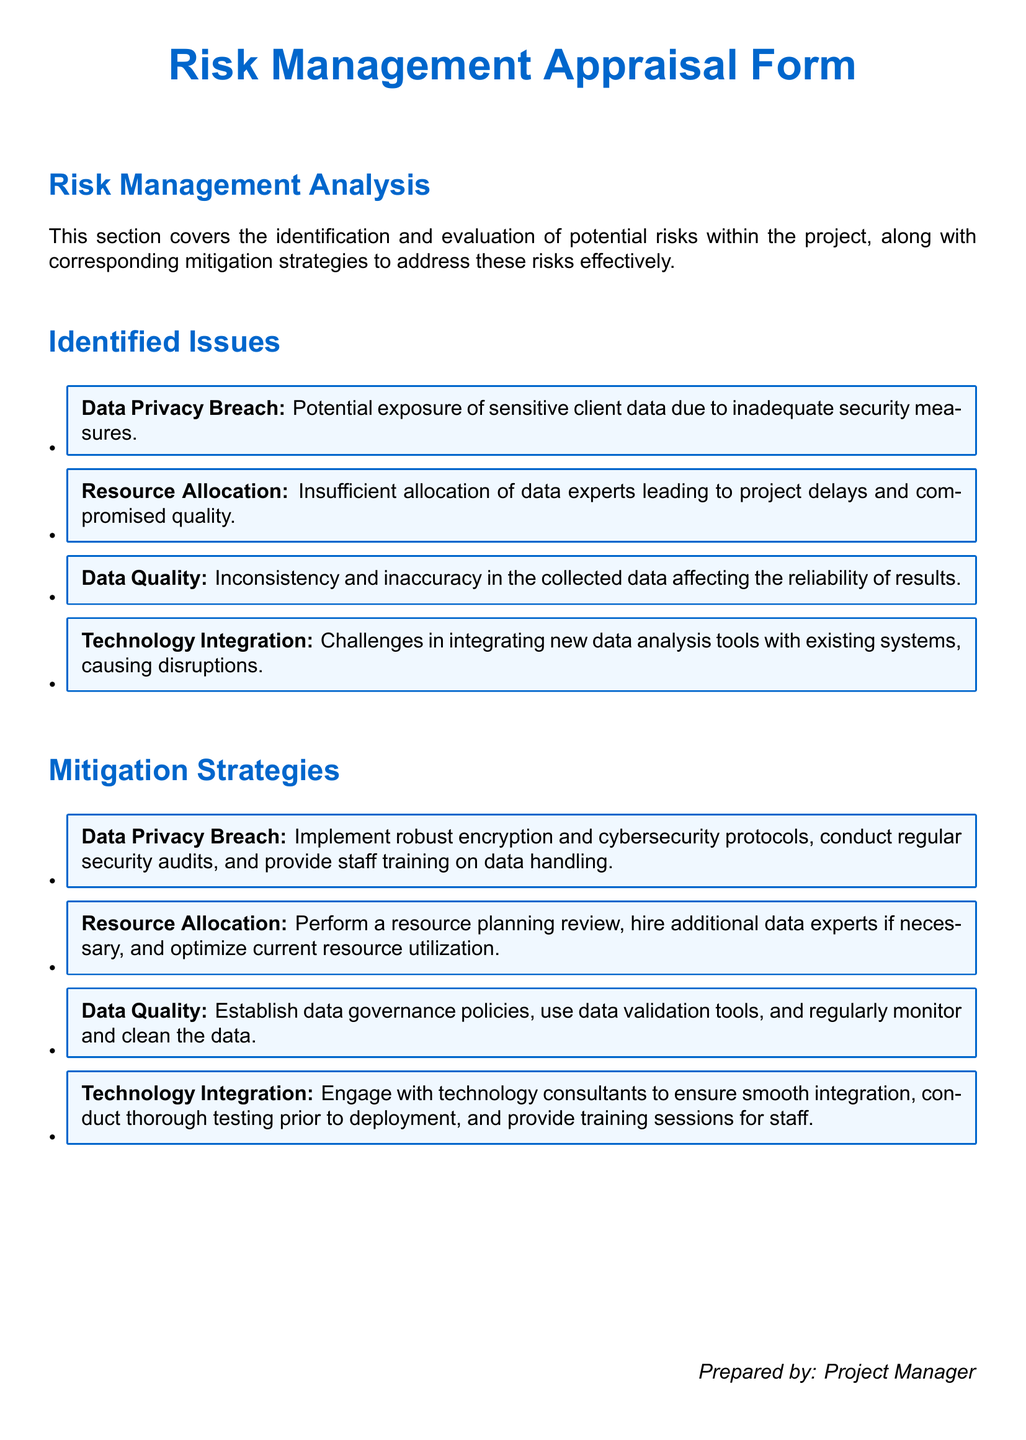What is the title of the document? The title is specified at the beginning of the document.
Answer: Risk Management Appraisal Form How many identified issues are listed? The number of identified issues can be counted from the list provided.
Answer: Four What is the first identified issue? The first issue mentioned in the identified issues section.
Answer: Data Privacy Breach What mitigation strategy is associated with Data Quality? This strategy can be found in the mitigation strategies section corresponding to the issue.
Answer: Establish data governance policies, use data validation tools, and regularly monitor and clean the data Who prepared the document? The preparer's information is provided at the bottom of the document.
Answer: Project Manager 